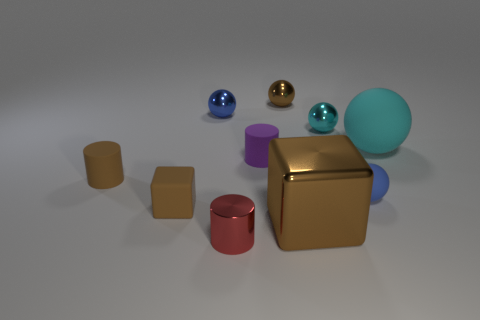Subtract all brown spheres. How many spheres are left? 4 Subtract all cyan balls. How many balls are left? 3 Subtract all cubes. How many objects are left? 8 Subtract all red cubes. How many brown spheres are left? 1 Subtract 0 cyan cubes. How many objects are left? 10 Subtract 2 cylinders. How many cylinders are left? 1 Subtract all gray balls. Subtract all gray cylinders. How many balls are left? 5 Subtract all tiny blue objects. Subtract all metallic cylinders. How many objects are left? 7 Add 4 cyan matte objects. How many cyan matte objects are left? 5 Add 9 large green matte objects. How many large green matte objects exist? 9 